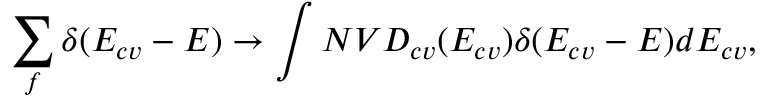<formula> <loc_0><loc_0><loc_500><loc_500>\sum _ { f } \delta ( E _ { c v } - E ) \rightarrow \int N V D _ { c v } ( E _ { c v } ) \delta ( E _ { c v } - E ) d E _ { c v } ,</formula> 